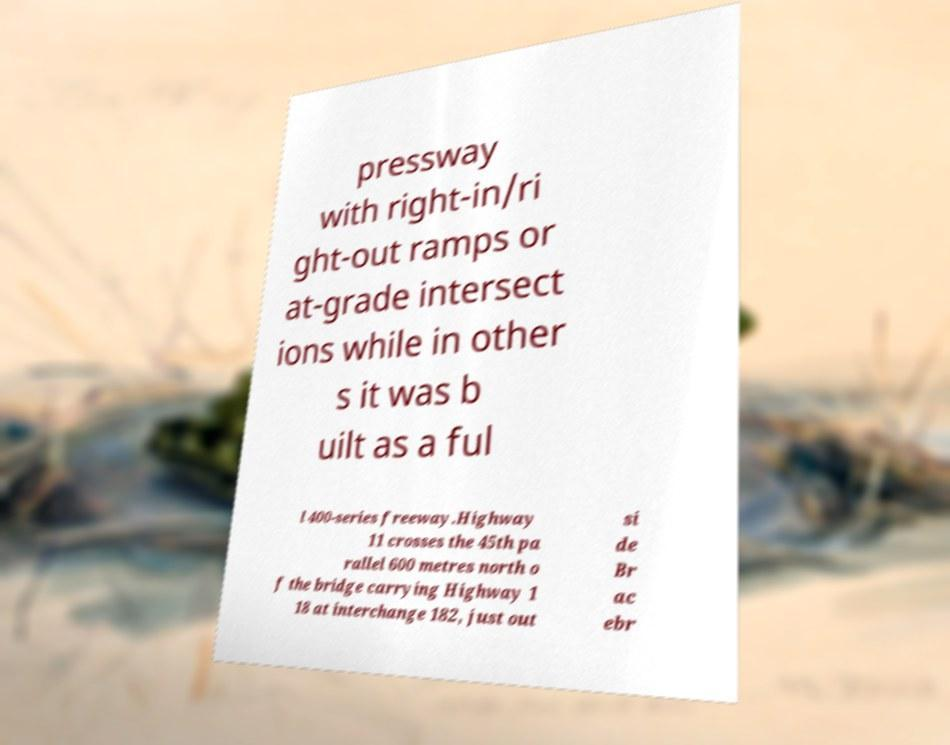What messages or text are displayed in this image? I need them in a readable, typed format. pressway with right-in/ri ght-out ramps or at-grade intersect ions while in other s it was b uilt as a ful l 400-series freeway.Highway 11 crosses the 45th pa rallel 600 metres north o f the bridge carrying Highway 1 18 at interchange 182, just out si de Br ac ebr 